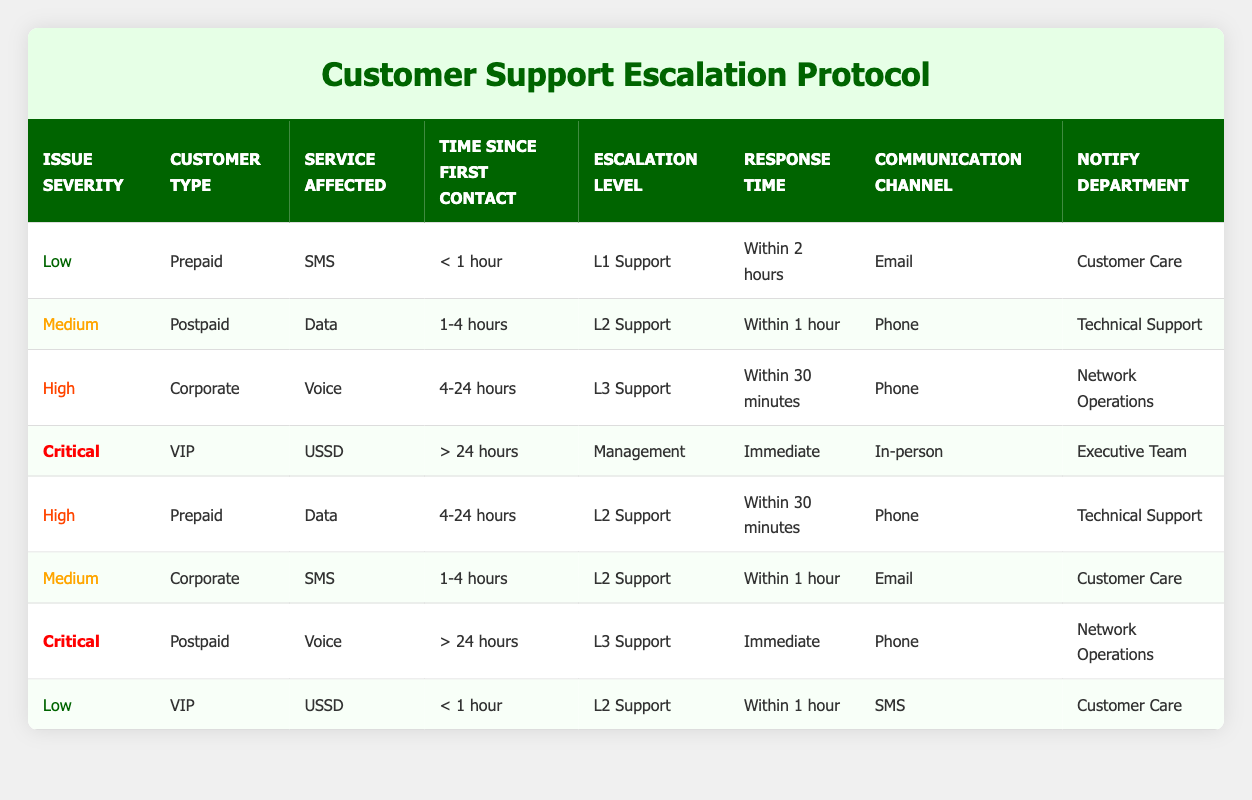What is the escalation level for a medium severity issue for a postpaid customer related to data within 1-4 hours? According to the table, a medium severity issue for a postpaid customer related to data within 1-4 hours corresponds to "L2 Support."
Answer: L2 Support How many total unique customer types are listed in the table? The table lists four unique customer types: Prepaid, Postpaid, Corporate, and VIP. Therefore, the total count is 4.
Answer: 4 Is it true that all critical issues are escalated to the management level? Yes, both instances of critical issues in the table (one for VIP and one for postpaid) have an escalation level of "Management." Thus, the statement is true.
Answer: Yes What is the response time for high severity issues for prepaid customers related to data within 4-24 hours? The table shows that for high severity issues for prepaid customers related to data within 4-24 hours, the response time is "Within 30 minutes."
Answer: Within 30 minutes Which department is notified for critical issues affecting the voice service for postpaid customers that have been in contact for more than 24 hours? The table indicates that for this scenario, the notification goes to "Network Operations."
Answer: Network Operations What is the average response time for issues with low severity? Analyzing the table, the response times for low severity issues are "Within 2 hours" and "Within 1 hour." To calculate the average, we can consider the approximated values roughly as 120 minutes and 60 minutes respectively. Hence, the average response time is (120 + 60) / 2 = 90 minutes.
Answer: 90 minutes For a critical issue affecting a VIP customer after more than 24 hours, what communication channel is used? According to the table, for this particular scenario, the communication channel used is "In-person."
Answer: In-person What is the escalation level for a low severity issue affecting a prepaid customer related to SMS within less than 1 hour? The table specifies that the escalation level in this case is "L1 Support."
Answer: L1 Support Is there a scenario where a corporate customer with a medium severity issue regarding SMS within 1-4 hours is handled by L3 support? No, the table indicates that a corporate customer with a medium severity issue regarding SMS within 1-4 hours is escalated to "L2 Support," not "L3 Support."
Answer: No 